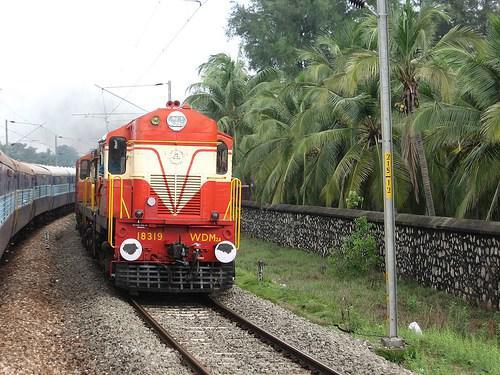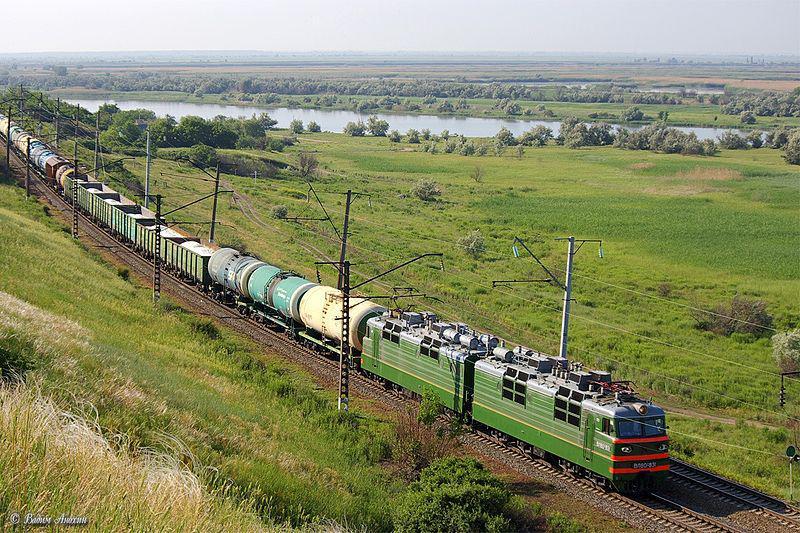The first image is the image on the left, the second image is the image on the right. Assess this claim about the two images: "Right image shows a green train moving in a rightward direction.". Correct or not? Answer yes or no. Yes. The first image is the image on the left, the second image is the image on the right. Examine the images to the left and right. Is the description "At least one of the trains in one of the images is passing through a grassy area." accurate? Answer yes or no. Yes. 